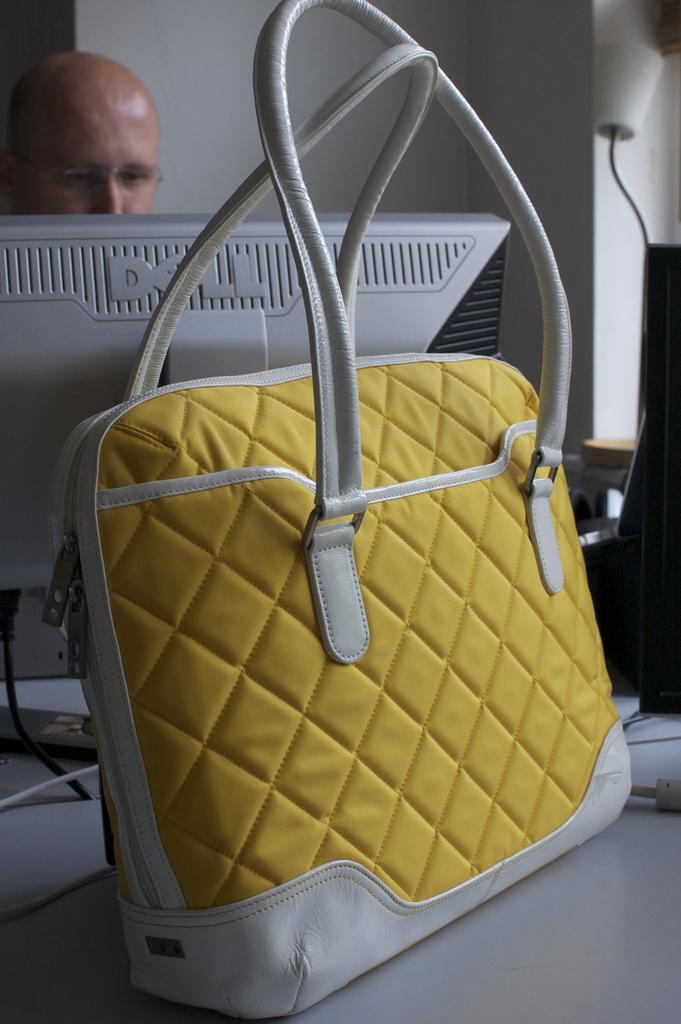How would you summarize this image in a sentence or two? In this picture we can see a person. This is table. On the table there is a bag and a monitor. On the background there is a wall. 